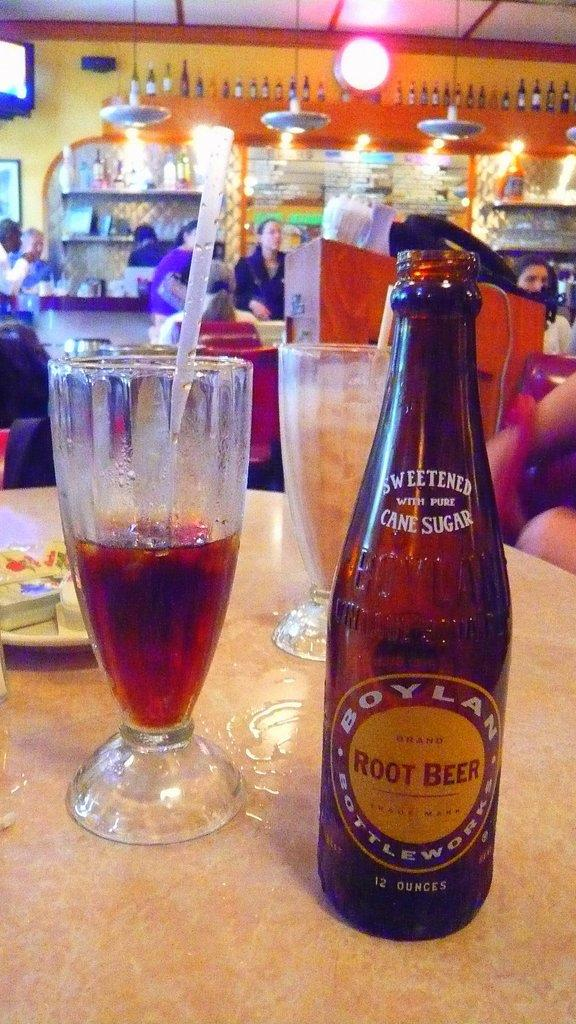<image>
Provide a brief description of the given image. A bottle of "BOYLAN" root beer is next to a glass. 